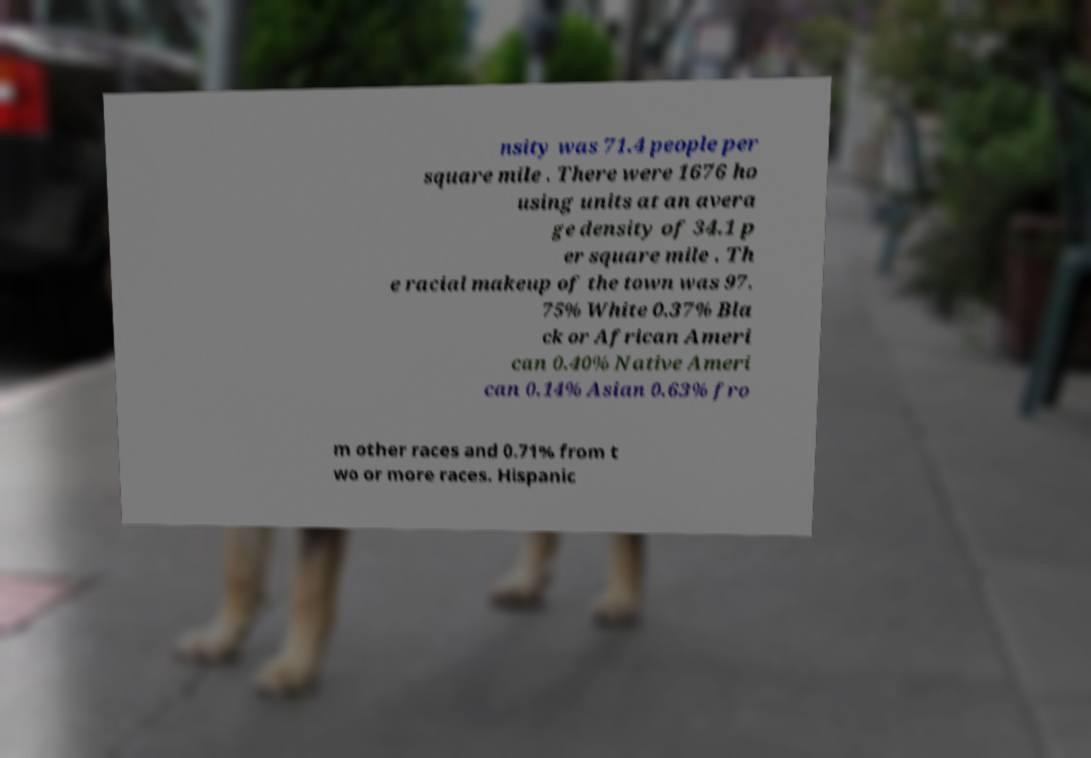Can you read and provide the text displayed in the image?This photo seems to have some interesting text. Can you extract and type it out for me? nsity was 71.4 people per square mile . There were 1676 ho using units at an avera ge density of 34.1 p er square mile . Th e racial makeup of the town was 97. 75% White 0.37% Bla ck or African Ameri can 0.40% Native Ameri can 0.14% Asian 0.63% fro m other races and 0.71% from t wo or more races. Hispanic 